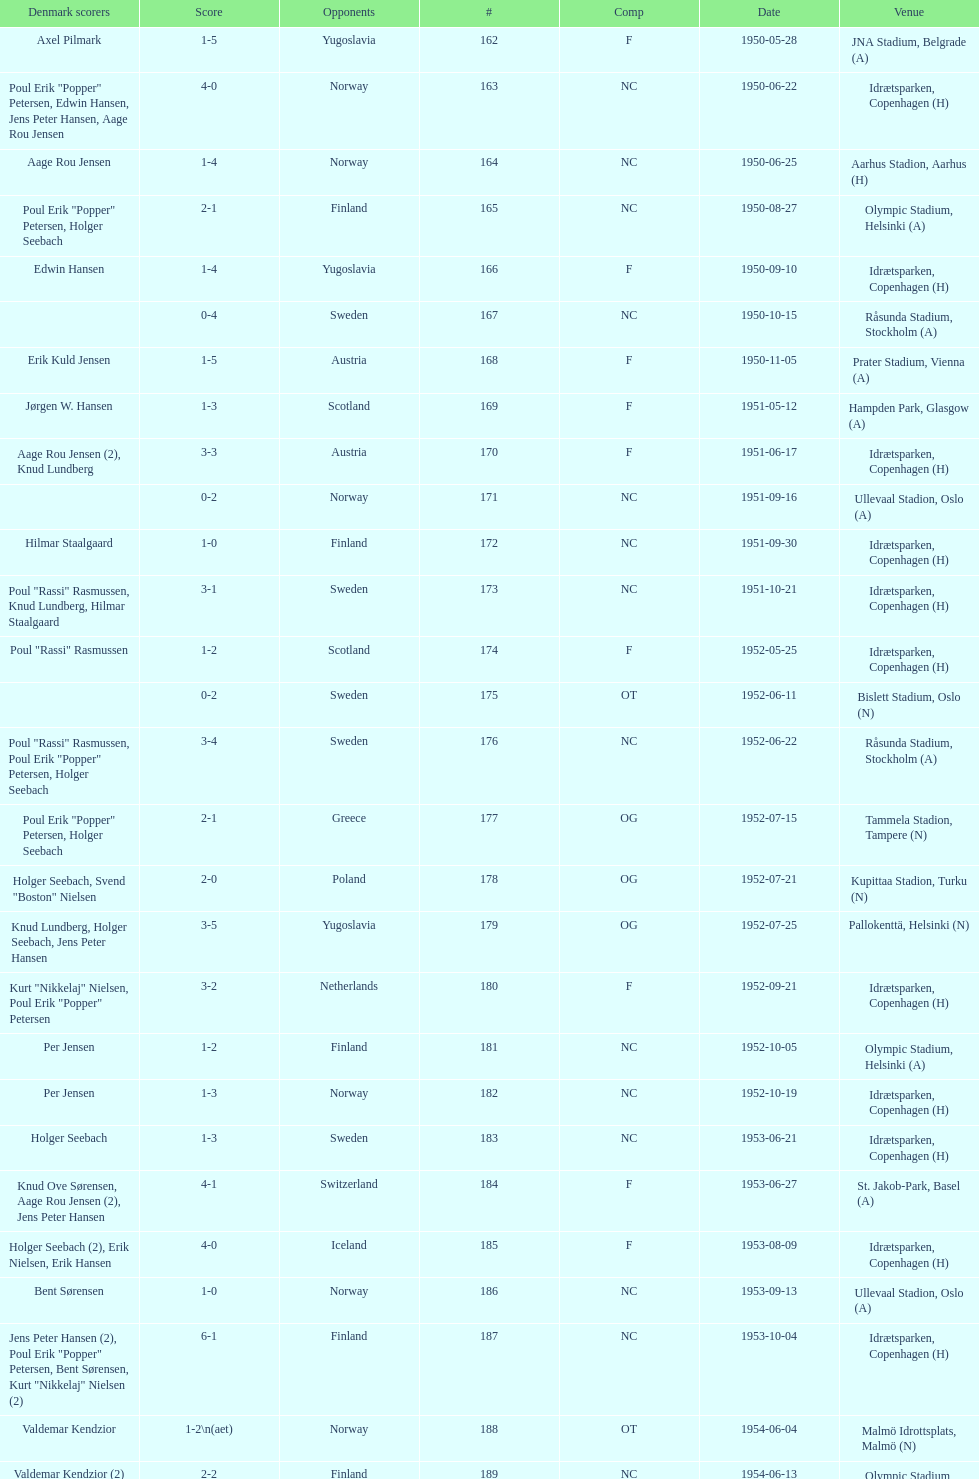Which overall score was greater, game #163 or #181? 163. 